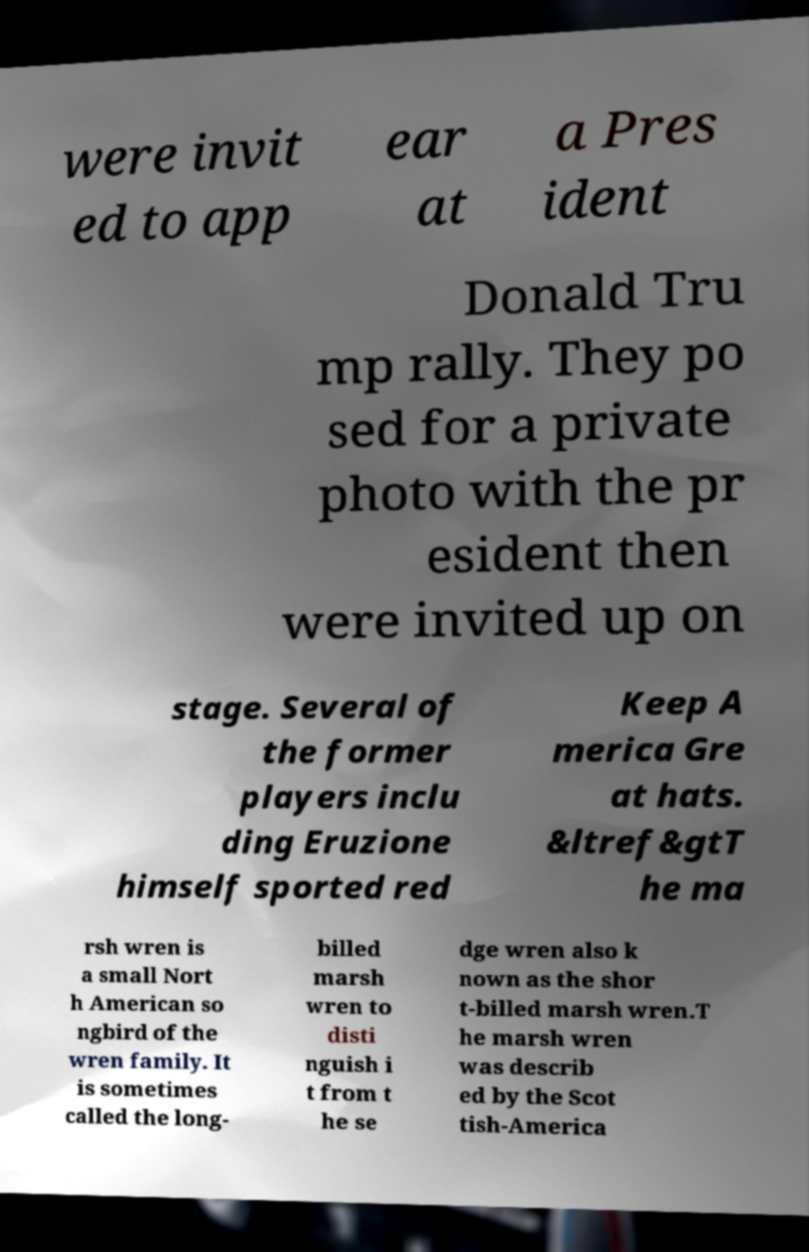Please identify and transcribe the text found in this image. were invit ed to app ear at a Pres ident Donald Tru mp rally. They po sed for a private photo with the pr esident then were invited up on stage. Several of the former players inclu ding Eruzione himself sported red Keep A merica Gre at hats. &ltref&gtT he ma rsh wren is a small Nort h American so ngbird of the wren family. It is sometimes called the long- billed marsh wren to disti nguish i t from t he se dge wren also k nown as the shor t-billed marsh wren.T he marsh wren was describ ed by the Scot tish-America 